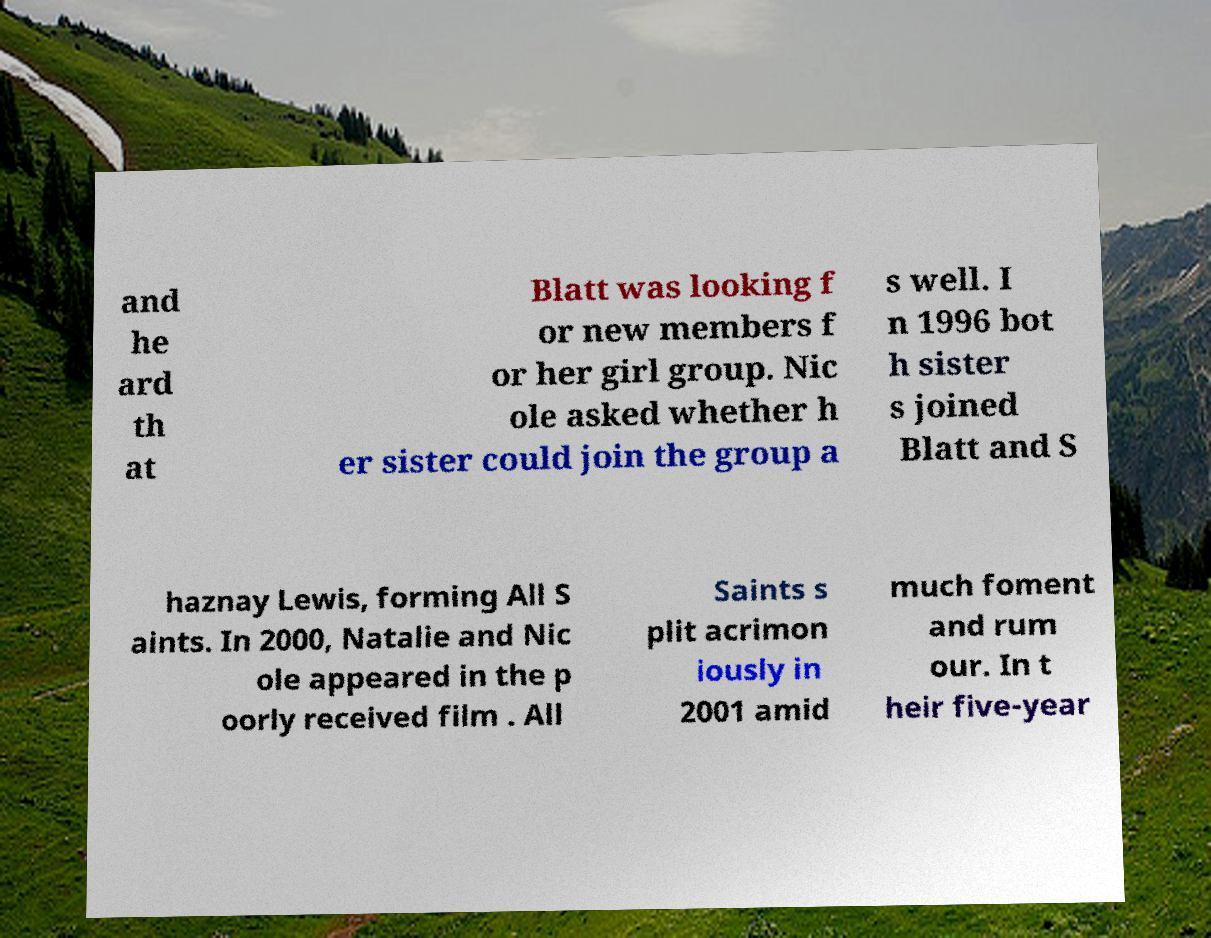What messages or text are displayed in this image? I need them in a readable, typed format. and he ard th at Blatt was looking f or new members f or her girl group. Nic ole asked whether h er sister could join the group a s well. I n 1996 bot h sister s joined Blatt and S haznay Lewis, forming All S aints. In 2000, Natalie and Nic ole appeared in the p oorly received film . All Saints s plit acrimon iously in 2001 amid much foment and rum our. In t heir five-year 